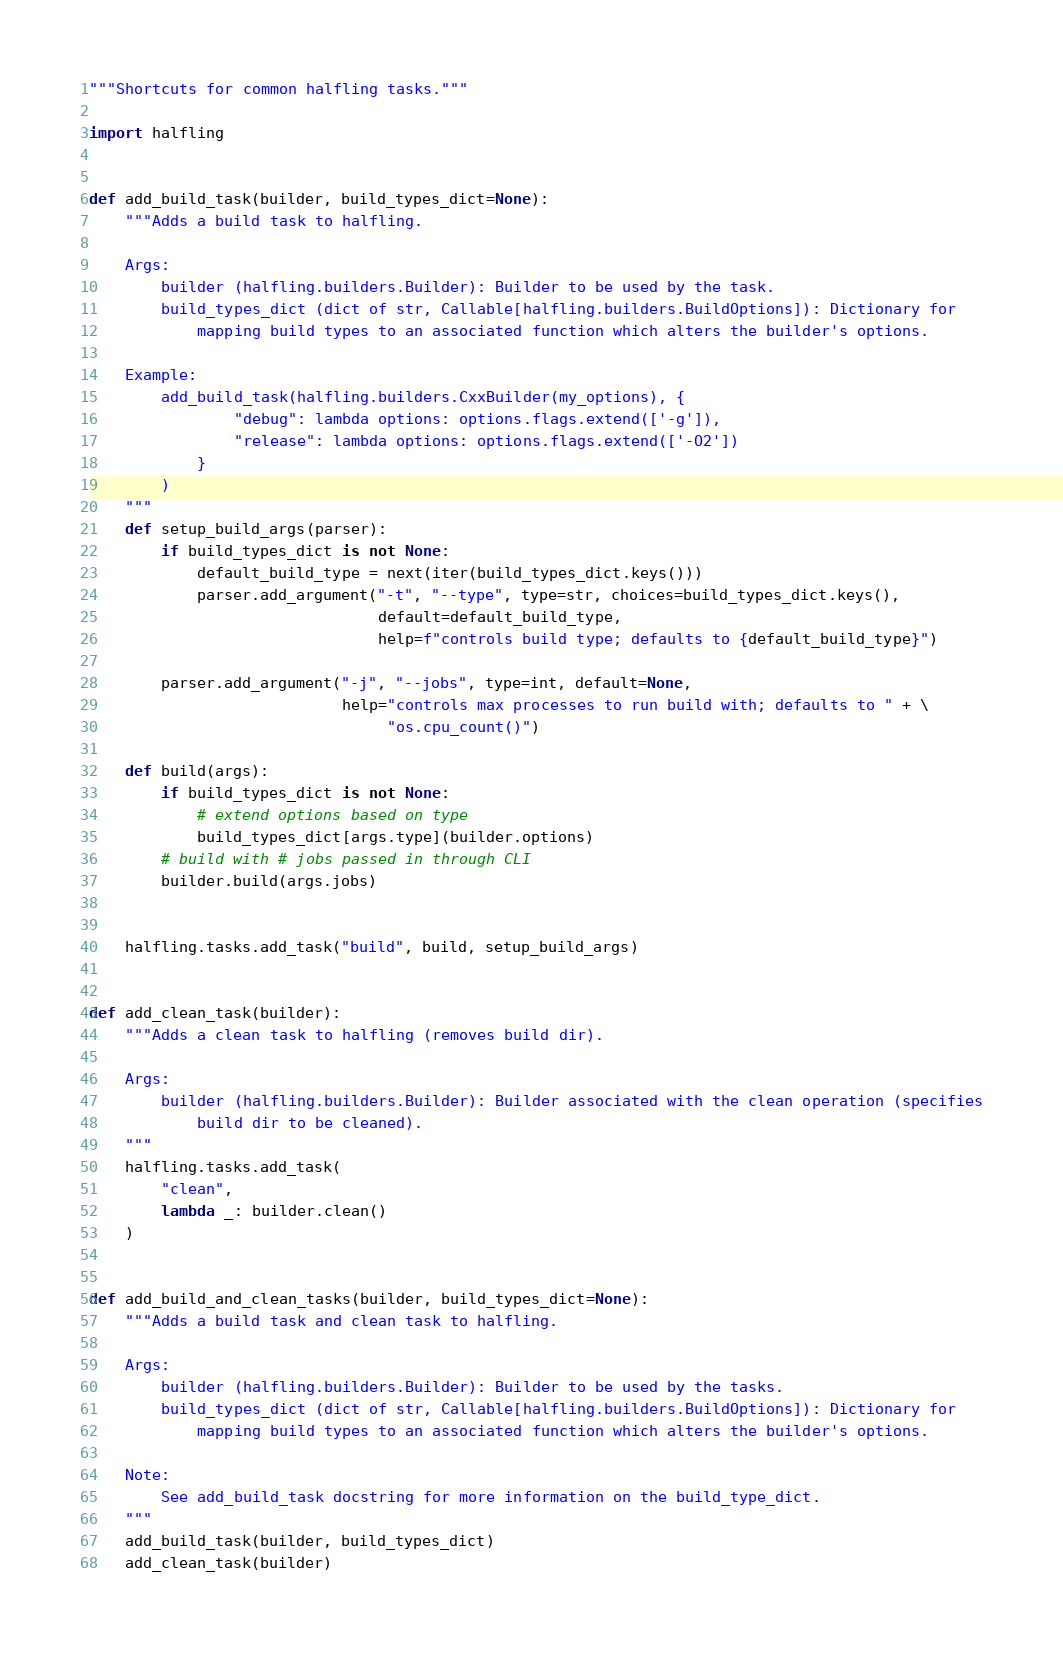<code> <loc_0><loc_0><loc_500><loc_500><_Python_>"""Shortcuts for common halfling tasks."""

import halfling


def add_build_task(builder, build_types_dict=None):
    """Adds a build task to halfling.

    Args:
        builder (halfling.builders.Builder): Builder to be used by the task.
        build_types_dict (dict of str, Callable[halfling.builders.BuildOptions]): Dictionary for 
            mapping build types to an associated function which alters the builder's options.

    Example:
        add_build_task(halfling.builders.CxxBuilder(my_options), {
                "debug": lambda options: options.flags.extend(['-g']),
                "release": lambda options: options.flags.extend(['-O2'])
            }
        )
    """
    def setup_build_args(parser):
        if build_types_dict is not None:
            default_build_type = next(iter(build_types_dict.keys()))
            parser.add_argument("-t", "--type", type=str, choices=build_types_dict.keys(),
                                default=default_build_type, 
                                help=f"controls build type; defaults to {default_build_type}")

        parser.add_argument("-j", "--jobs", type=int, default=None,
                            help="controls max processes to run build with; defaults to " + \
                                 "os.cpu_count()")

    def build(args):
        if build_types_dict is not None:
            # extend options based on type
            build_types_dict[args.type](builder.options)
        # build with # jobs passed in through CLI
        builder.build(args.jobs)


    halfling.tasks.add_task("build", build, setup_build_args)


def add_clean_task(builder):
    """Adds a clean task to halfling (removes build dir).

    Args:
        builder (halfling.builders.Builder): Builder associated with the clean operation (specifies
            build dir to be cleaned).
    """
    halfling.tasks.add_task(
        "clean",
        lambda _: builder.clean()
    )


def add_build_and_clean_tasks(builder, build_types_dict=None):
    """Adds a build task and clean task to halfling.

    Args:
        builder (halfling.builders.Builder): Builder to be used by the tasks.
        build_types_dict (dict of str, Callable[halfling.builders.BuildOptions]): Dictionary for 
            mapping build types to an associated function which alters the builder's options.

    Note:
        See add_build_task docstring for more information on the build_type_dict.
    """
    add_build_task(builder, build_types_dict)
    add_clean_task(builder)
</code> 